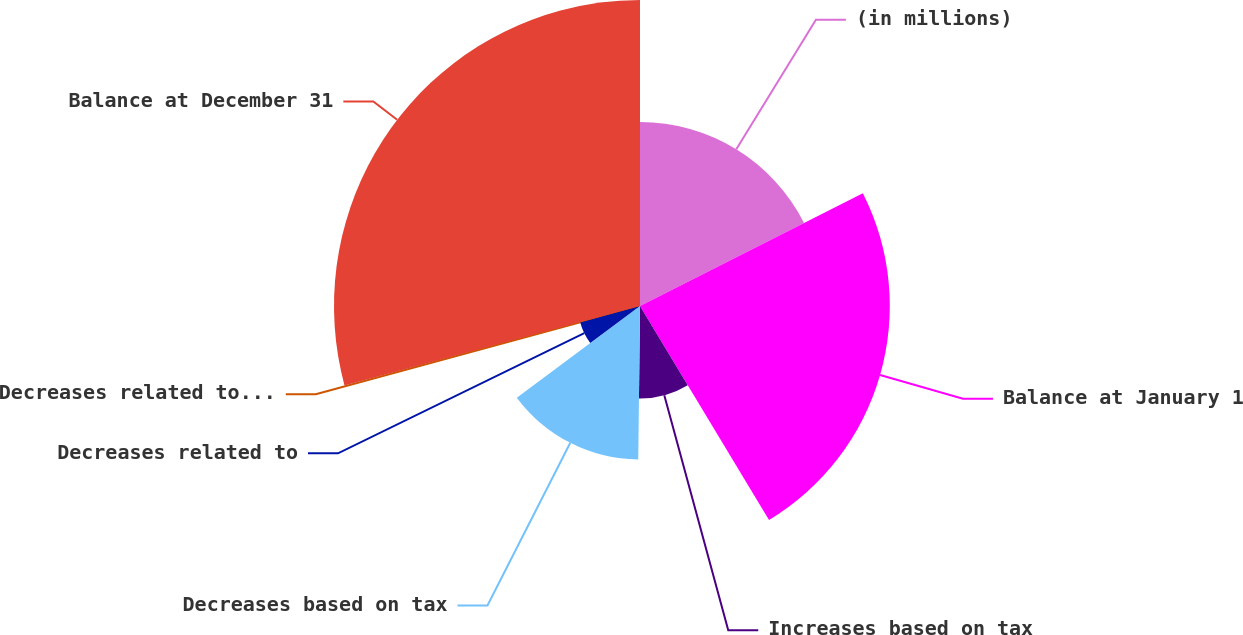Convert chart to OTSL. <chart><loc_0><loc_0><loc_500><loc_500><pie_chart><fcel>(in millions)<fcel>Balance at January 1<fcel>Increases based on tax<fcel>Decreases based on tax<fcel>Decreases related to<fcel>Decreases related to a lapse<fcel>Balance at December 31<nl><fcel>17.54%<fcel>23.82%<fcel>8.82%<fcel>14.64%<fcel>5.91%<fcel>0.09%<fcel>29.18%<nl></chart> 